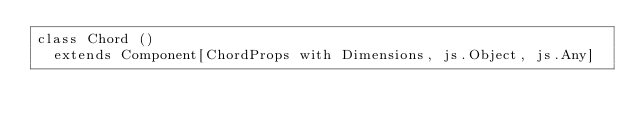<code> <loc_0><loc_0><loc_500><loc_500><_Scala_>class Chord ()
  extends Component[ChordProps with Dimensions, js.Object, js.Any]
</code> 